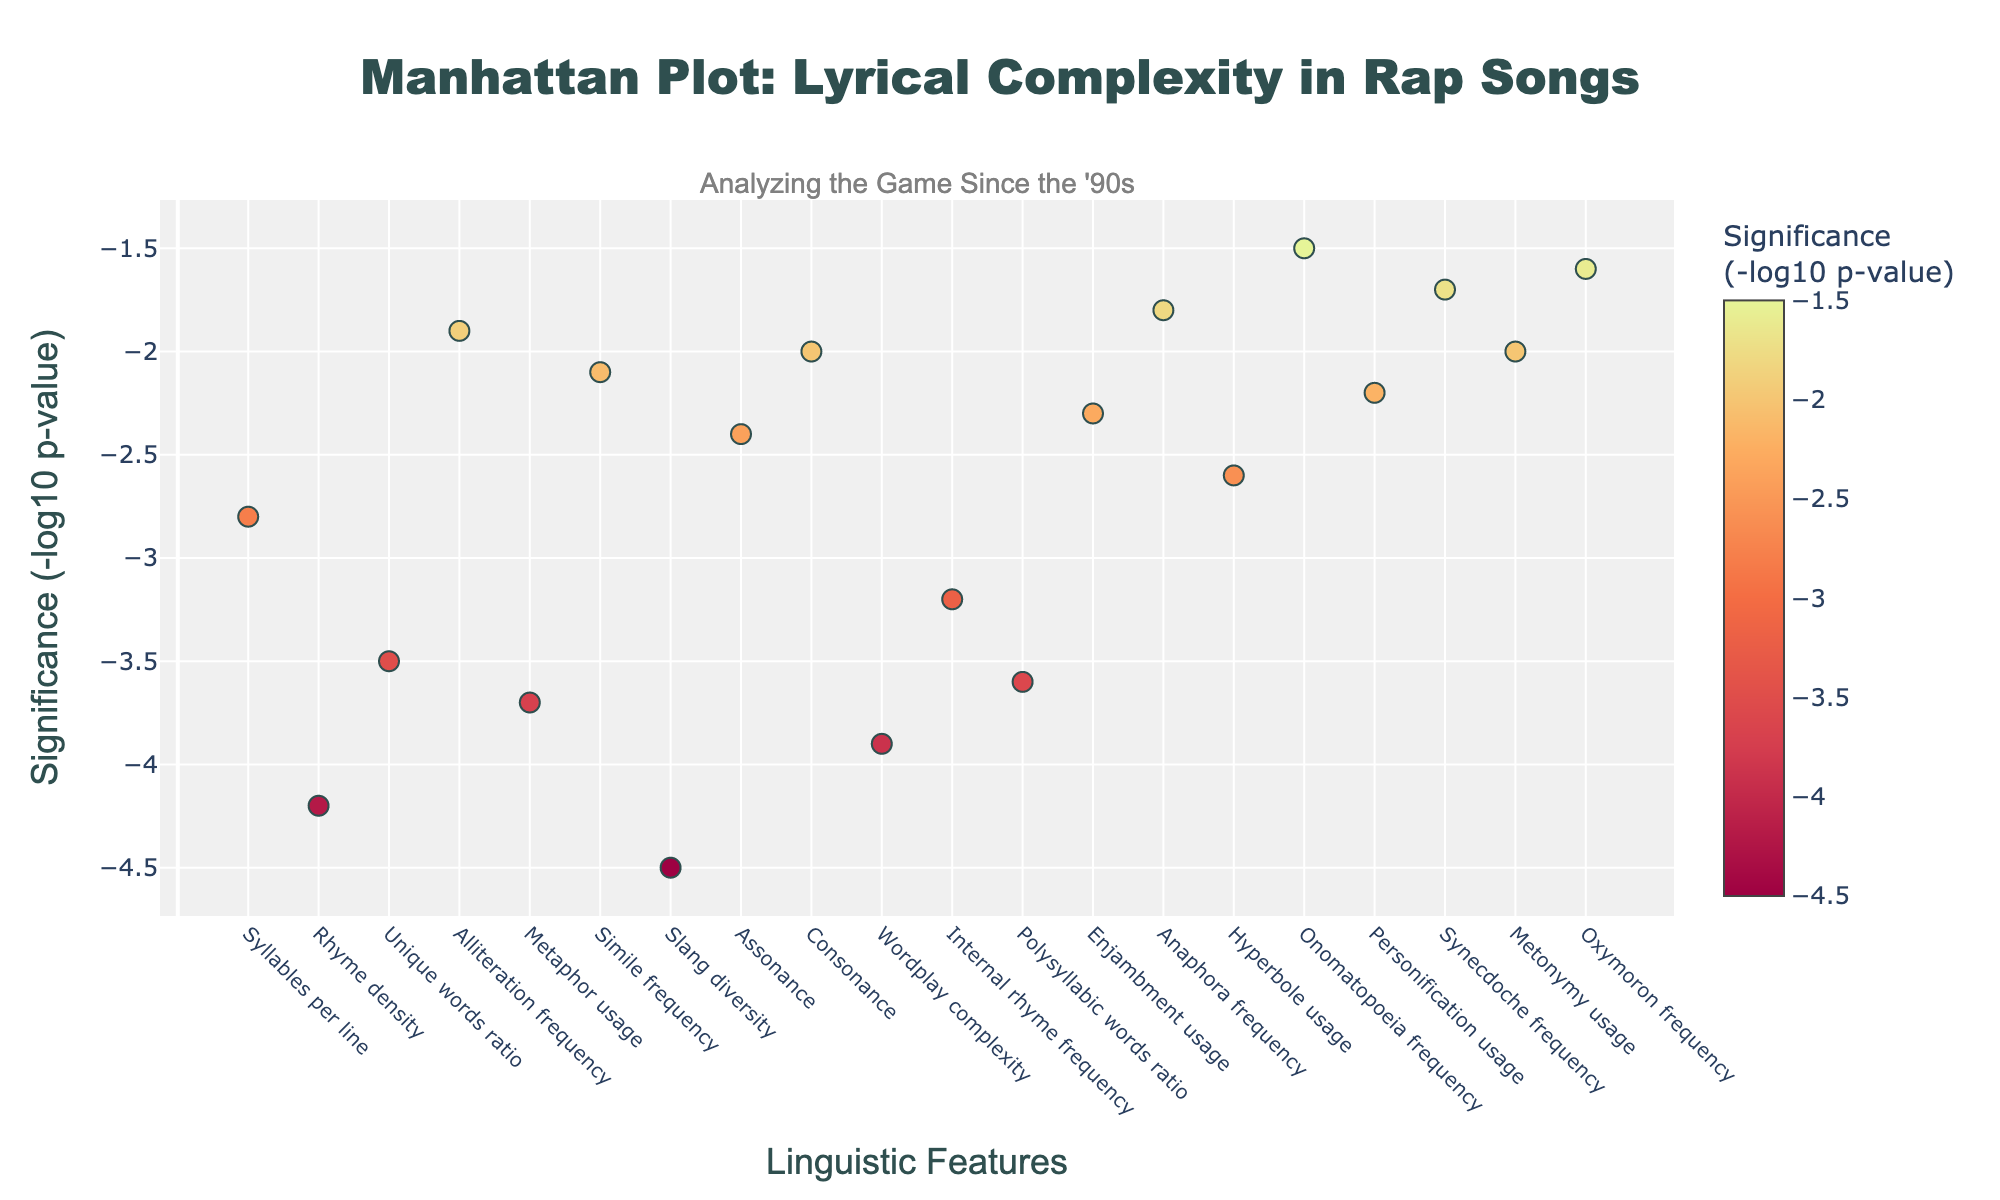Which linguistic feature has the highest significance? The plot displays significance as -log10 of the p-value for each linguistic feature. The one with the highest value on the y-axis is the most significant. "Slang diversity" has the highest significance with a -log10(p-value) of 4.5.
Answer: Slang diversity How is the significance of rhyme density compared to alliteration frequency? Check the y-axis values for both features. Rhyme density has a -log10(p-value) of 4.2, while alliteration frequency is significantly lower at 1.9.
Answer: Rhyme density is more significant Which linguistic features have a significance less than 2? Look for the features with y-values less than 2. These are "Alliteration frequency," "Anaphora frequency," "Onomatopoeia frequency," "Synecdoche frequency," "Metonymy usage," and "Oxymoron frequency."
Answer: Alliteration frequency, Anaphora frequency, Onomatopoeia frequency, Synecdoche frequency, Metonymy usage, Oxymoron frequency Count the number of linguistic features with significance above 3.0. Identify and count the features with y-values greater than 3.0. These are "Rhyme density," "Unique words ratio," "Metaphor usage," "Slang diversity," "Wordplay complexity," "Internal rhyme frequency," and "Polysyllabic words ratio."
Answer: 7 What is the difference in significance between polysyllabic words ratio and enjambment usage? Check the y-axis values for both features. Polysyllabic words ratio has a significance of 3.6, and enjambment usage has 2.3. The difference is 3.6 - 2.3.
Answer: 1.3 Which feature is more significant: simile frequency or hyperbole usage? Compare their y-axis values. Simile frequency has a significance of 2.1, whereas hyperbole usage has 2.6.
Answer: Hyperbole usage What is the average significance of metaphor usage and internal rhyme frequency? Find the y-axis values for both features. Metaphor usage is at 3.7, and internal rhyme frequency is at 3.2. The average is (3.7 + 3.2) / 2.
Answer: 3.45 Identify the linguistic feature with the lowest significance. Look for the feature with the lowest y-axis value. "Onomatopoeia frequency" has the lowest significance at 1.5.
Answer: Onomatopoeia frequency Calculate the total significance of the top 3 most significant features. Determine the top 3 features ("Slang diversity," "Rhyme density," "Metaphor usage") and sum their significance values: 4.5 + 4.2 + 3.9.
Answer: 12.6 Which characteristic falls exactly in the middle in terms of position? Count the number of characteristics and find the middle one. With 20 characteristics, the middle is the 10th. "Wordplay complexity" is the 10th feature.
Answer: Wordplay complexity 